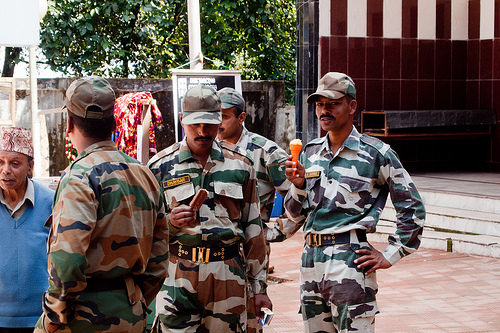<image>
Is the hat on the man? Yes. Looking at the image, I can see the hat is positioned on top of the man, with the man providing support. 